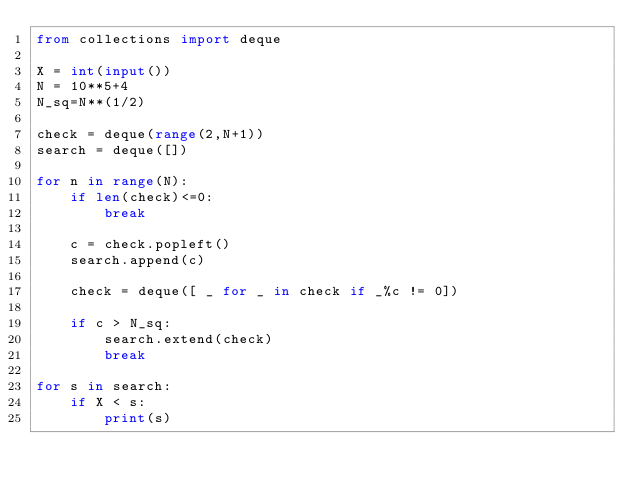<code> <loc_0><loc_0><loc_500><loc_500><_Python_>from collections import deque

X = int(input())
N = 10**5+4
N_sq=N**(1/2)

check = deque(range(2,N+1))
search = deque([])

for n in range(N):
    if len(check)<=0:
        break
        
    c = check.popleft()
    search.append(c)

    check = deque([ _ for _ in check if _%c != 0])
    
    if c > N_sq:
        search.extend(check)
        break
        
for s in search:
    if X < s:
        print(s)</code> 